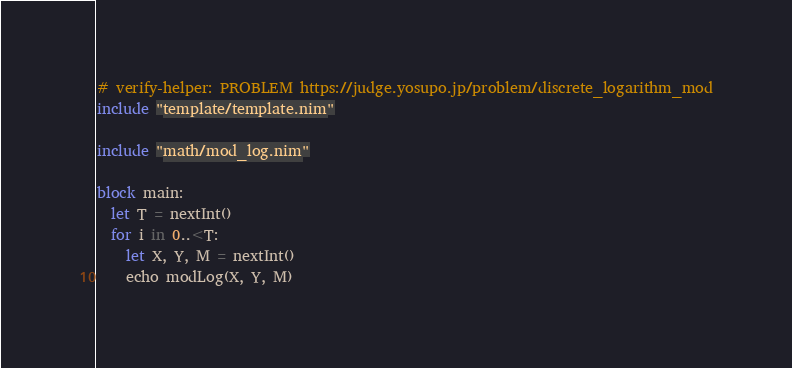<code> <loc_0><loc_0><loc_500><loc_500><_Nim_># verify-helper: PROBLEM https://judge.yosupo.jp/problem/discrete_logarithm_mod
include "template/template.nim"

include "math/mod_log.nim"

block main:
  let T = nextInt()
  for i in 0..<T:
    let X, Y, M = nextInt()
    echo modLog(X, Y, M)
</code> 